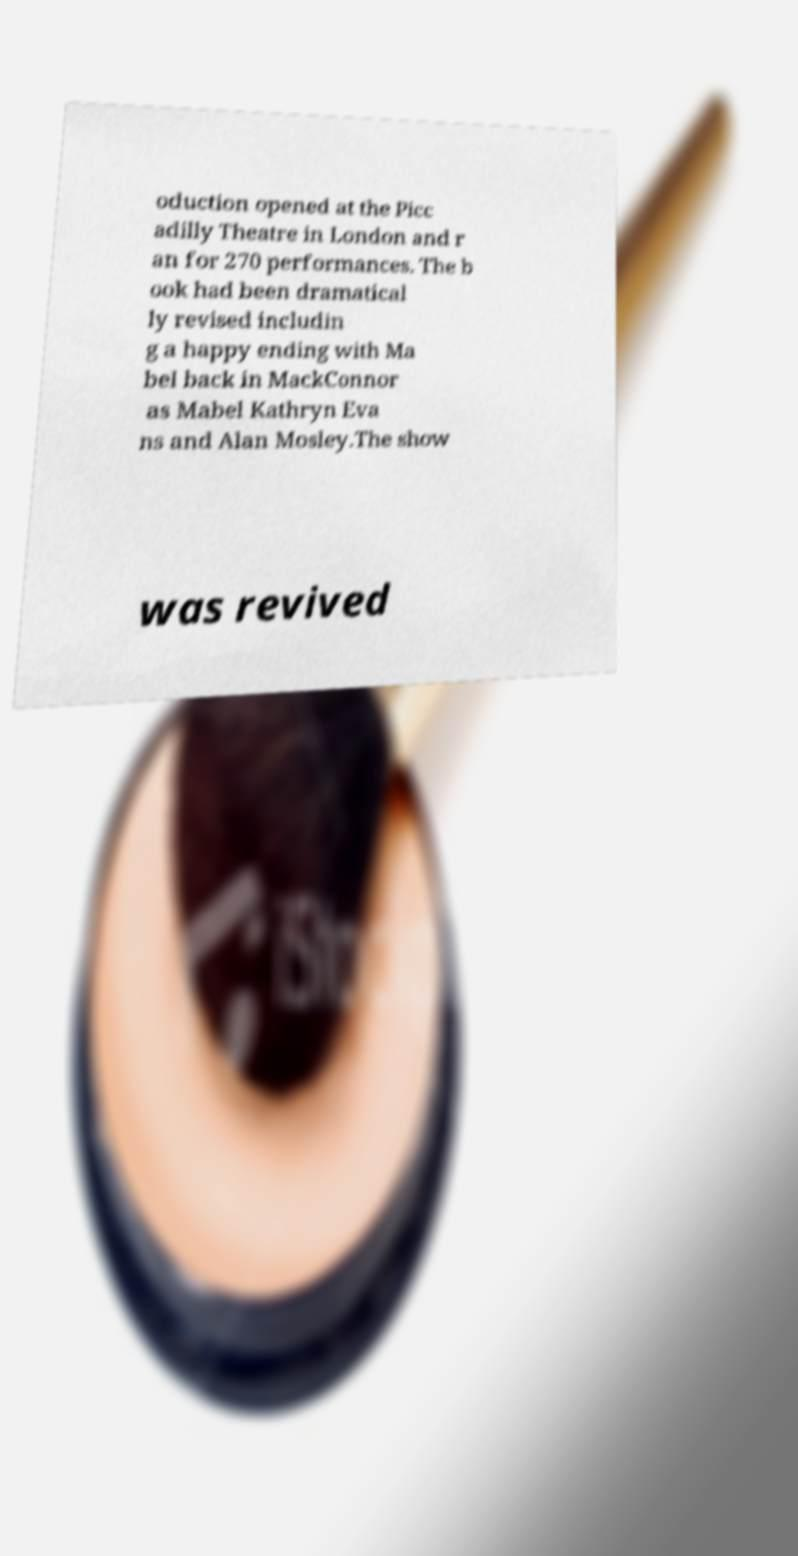I need the written content from this picture converted into text. Can you do that? oduction opened at the Picc adilly Theatre in London and r an for 270 performances. The b ook had been dramatical ly revised includin g a happy ending with Ma bel back in MackConnor as Mabel Kathryn Eva ns and Alan Mosley.The show was revived 